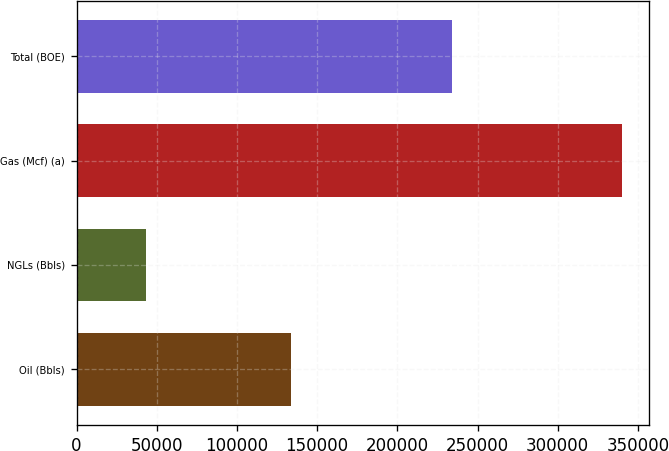Convert chart to OTSL. <chart><loc_0><loc_0><loc_500><loc_500><bar_chart><fcel>Oil (Bbls)<fcel>NGLs (Bbls)<fcel>Gas (Mcf) (a)<fcel>Total (BOE)<nl><fcel>133677<fcel>43504<fcel>339966<fcel>233842<nl></chart> 